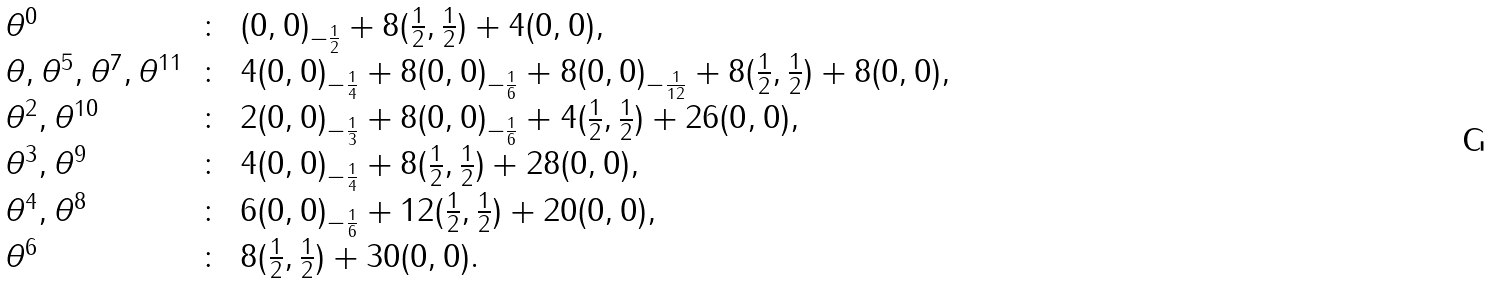<formula> <loc_0><loc_0><loc_500><loc_500>\begin{array} { l c l } \theta ^ { 0 } & \colon & ( 0 , 0 ) _ { - \frac { 1 } { 2 } } + 8 ( \frac { 1 } { 2 } , \frac { 1 } { 2 } ) + 4 ( 0 , 0 ) , \\ \theta , \theta ^ { 5 } , \theta ^ { 7 } , \theta ^ { 1 1 } & \colon & 4 ( 0 , 0 ) _ { - \frac { 1 } { 4 } } + 8 ( 0 , 0 ) _ { - \frac { 1 } { 6 } } + 8 ( 0 , 0 ) _ { - \frac { 1 } { 1 2 } } + 8 ( \frac { 1 } { 2 } , \frac { 1 } { 2 } ) + 8 ( 0 , 0 ) , \\ \theta ^ { 2 } , \theta ^ { 1 0 } & \colon & 2 ( 0 , 0 ) _ { - \frac { 1 } { 3 } } + 8 ( 0 , 0 ) _ { - \frac { 1 } { 6 } } + 4 ( \frac { 1 } { 2 } , \frac { 1 } { 2 } ) + 2 6 ( 0 , 0 ) , \\ \theta ^ { 3 } , \theta ^ { 9 } & \colon & 4 ( 0 , 0 ) _ { - \frac { 1 } { 4 } } + 8 ( \frac { 1 } { 2 } , \frac { 1 } { 2 } ) + 2 8 ( 0 , 0 ) , \\ \theta ^ { 4 } , \theta ^ { 8 } & \colon & 6 ( 0 , 0 ) _ { - \frac { 1 } { 6 } } + 1 2 ( \frac { 1 } { 2 } , \frac { 1 } { 2 } ) + 2 0 ( 0 , 0 ) , \\ \theta ^ { 6 } & \colon & 8 ( \frac { 1 } { 2 } , \frac { 1 } { 2 } ) + 3 0 ( 0 , 0 ) . \end{array}</formula> 